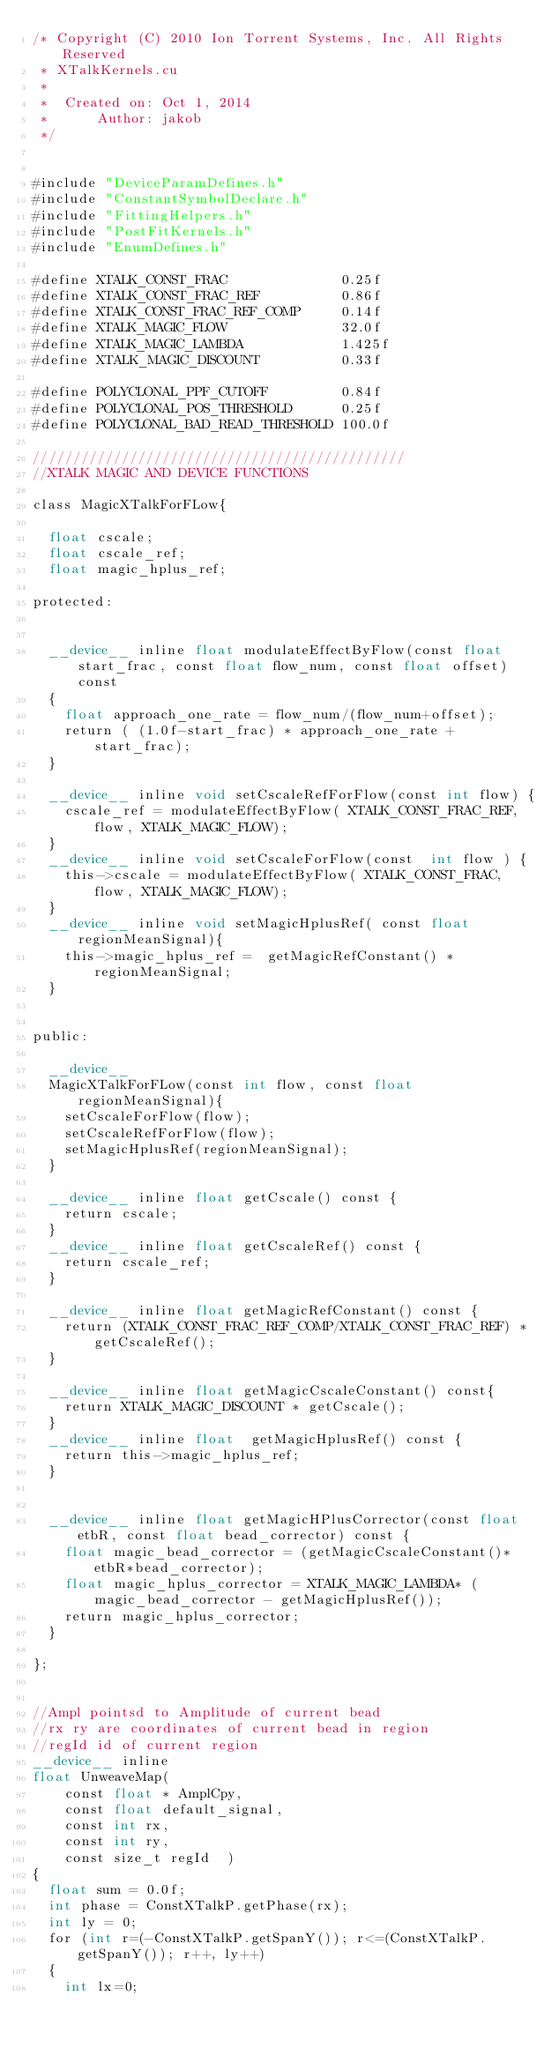<code> <loc_0><loc_0><loc_500><loc_500><_Cuda_>/* Copyright (C) 2010 Ion Torrent Systems, Inc. All Rights Reserved
 * XTalkKernels.cu
 *
 *  Created on: Oct 1, 2014
 *      Author: jakob
 */


#include "DeviceParamDefines.h"
#include "ConstantSymbolDeclare.h"
#include "FittingHelpers.h"
#include "PostFitKernels.h"
#include "EnumDefines.h"

#define XTALK_CONST_FRAC              0.25f
#define XTALK_CONST_FRAC_REF          0.86f
#define XTALK_CONST_FRAC_REF_COMP     0.14f
#define XTALK_MAGIC_FLOW              32.0f
#define XTALK_MAGIC_LAMBDA            1.425f
#define XTALK_MAGIC_DISCOUNT          0.33f

#define POLYCLONAL_PPF_CUTOFF         0.84f
#define POLYCLONAL_POS_THRESHOLD      0.25f
#define POLYCLONAL_BAD_READ_THRESHOLD 100.0f

//////////////////////////////////////////////
//XTALK MAGIC AND DEVICE FUNCTIONS

class MagicXTalkForFLow{

  float cscale;
  float cscale_ref;
  float magic_hplus_ref;

protected:


  __device__ inline float modulateEffectByFlow(const float start_frac, const float flow_num, const float offset) const
  {
    float approach_one_rate = flow_num/(flow_num+offset);
    return ( (1.0f-start_frac) * approach_one_rate + start_frac);
  }

  __device__ inline void setCscaleRefForFlow(const int flow) {
    cscale_ref = modulateEffectByFlow( XTALK_CONST_FRAC_REF, flow, XTALK_MAGIC_FLOW);
  }
  __device__ inline void setCscaleForFlow(const  int flow ) {
    this->cscale = modulateEffectByFlow( XTALK_CONST_FRAC, flow, XTALK_MAGIC_FLOW);
  }
  __device__ inline void setMagicHplusRef( const float regionMeanSignal){
    this->magic_hplus_ref =  getMagicRefConstant() * regionMeanSignal;
  }


public:

  __device__
  MagicXTalkForFLow(const int flow, const float regionMeanSignal){
    setCscaleForFlow(flow);
    setCscaleRefForFlow(flow);
    setMagicHplusRef(regionMeanSignal);
  }

  __device__ inline float getCscale() const {
    return cscale;
  }
  __device__ inline float getCscaleRef() const {
    return cscale_ref;
  }

  __device__ inline float getMagicRefConstant() const {
    return (XTALK_CONST_FRAC_REF_COMP/XTALK_CONST_FRAC_REF) * getCscaleRef();
  }

  __device__ inline float getMagicCscaleConstant() const{
    return XTALK_MAGIC_DISCOUNT * getCscale();
  }
  __device__ inline float  getMagicHplusRef() const {
    return this->magic_hplus_ref;
  }


  __device__ inline float getMagicHPlusCorrector(const float etbR, const float bead_corrector) const {
    float magic_bead_corrector = (getMagicCscaleConstant()*etbR*bead_corrector);
    float magic_hplus_corrector = XTALK_MAGIC_LAMBDA* ( magic_bead_corrector - getMagicHplusRef());
    return magic_hplus_corrector;
  }

};


//Ampl pointsd to Amplitude of current bead
//rx ry are coordinates of current bead in region
//regId id of current region
__device__ inline
float UnweaveMap(
    const float * AmplCpy,
    const float default_signal,
    const int rx,
    const int ry,
    const size_t regId  )
{
  float sum = 0.0f;
  int phase = ConstXTalkP.getPhase(rx);
  int ly = 0;
  for (int r=(-ConstXTalkP.getSpanY()); r<=(ConstXTalkP.getSpanY()); r++, ly++)
  {
    int lx=0;</code> 